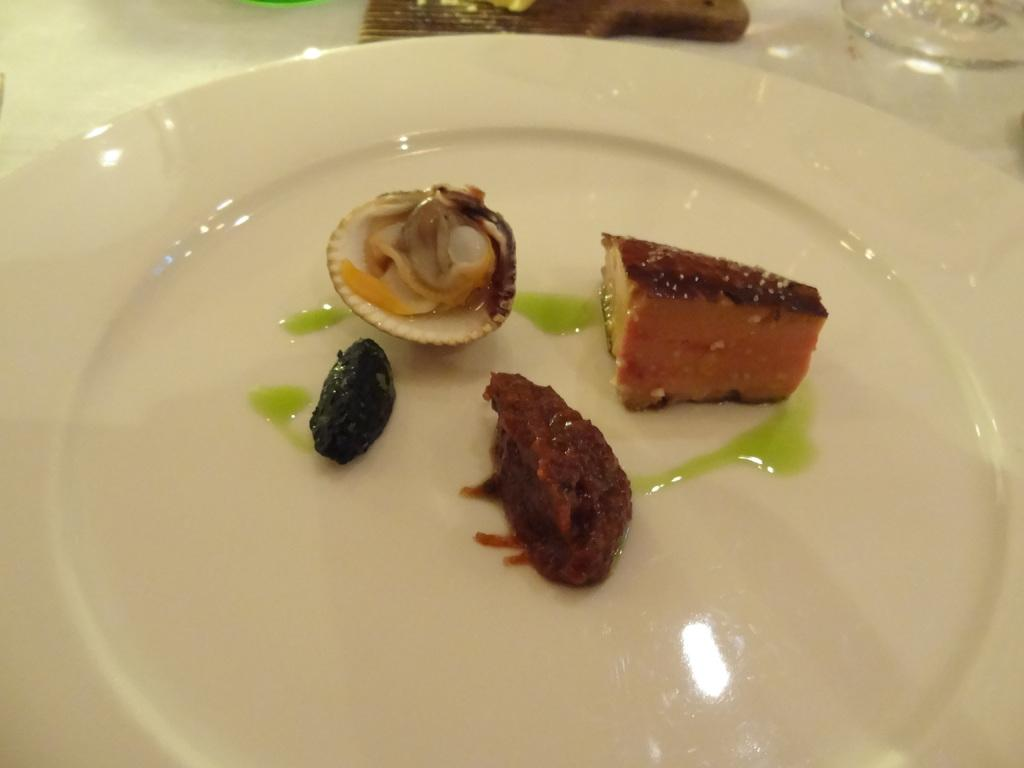What is placed on the white plate in the image? There are eatables placed on a white plate in the image. Can you describe any other objects visible in the background of the image? Unfortunately, the provided facts do not give any information about the objects visible in the background of the image. What type of legal advice is the lawyer providing in the image? There is no lawyer present in the image, so it is not possible to answer that question. 